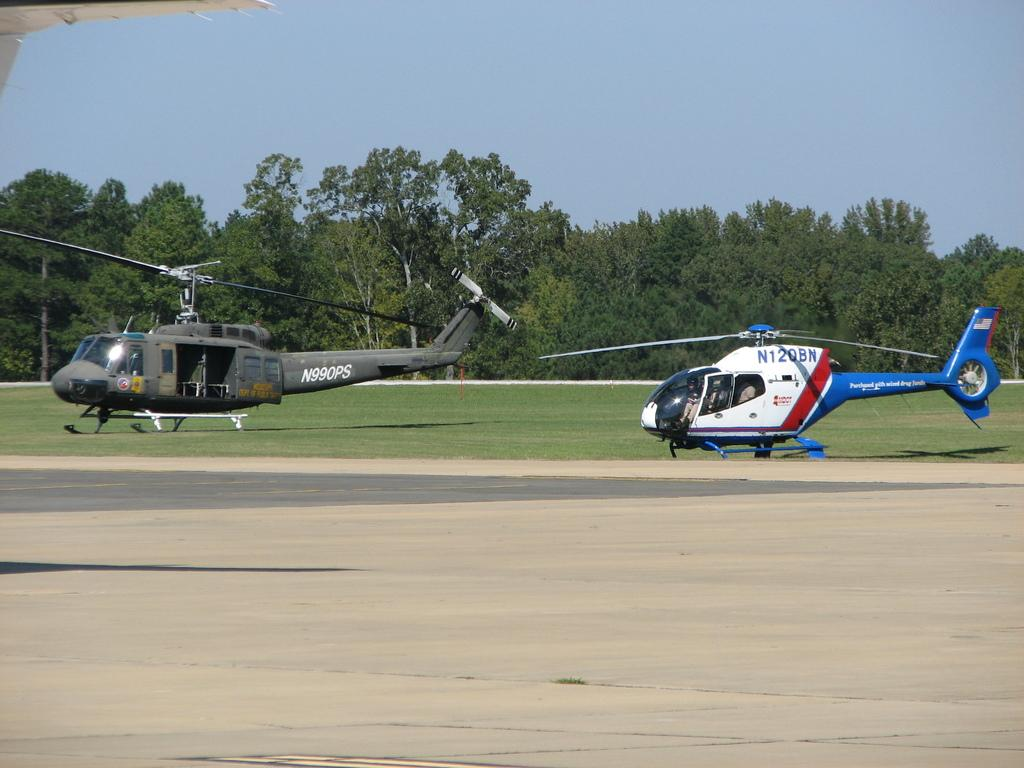What can be seen in the image that flies and has rotors? There are two helicopters in the image. Can you describe the possible occupants of the helicopters? There may be people sitting inside the helicopters. What type of vegetation is present in the image? There are trees with branches and leaves in the image. What is the ground cover visible in the image? There is grass visible in the image. Are there any houses visible in the image, and if so, how deep are they in the quicksand? There are no houses present in the image, and therefore no quicksand or depth measurements can be made. 